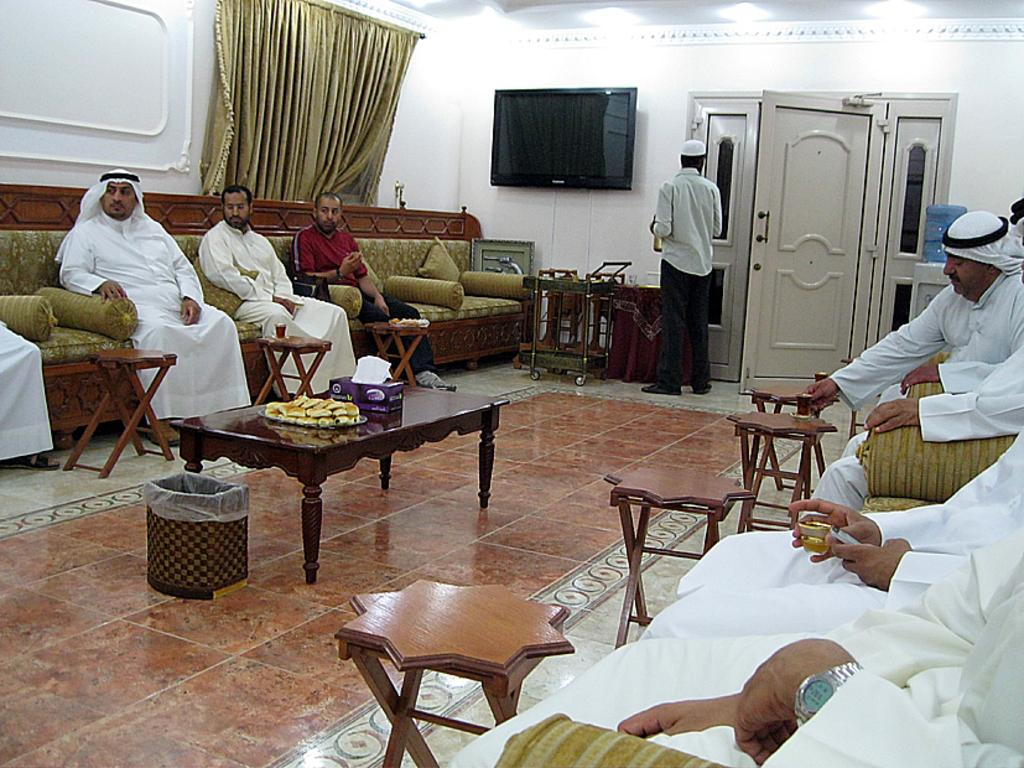What are the people in the image doing? The people in the image are sitting on sofas. What other furniture can be seen in the image? There are tables in the image. What is the man in the image doing? There is a man standing in the image. What is a feature of the room that can be used for entering or exiting? There is a door in the image. What type of electronic device is present on the wall? There is a black color television on the wall in the image. Can you provide an example of a spoon used by the people sitting on the sofas in the image? There is no spoon present in the image; the people are not using any utensils. 